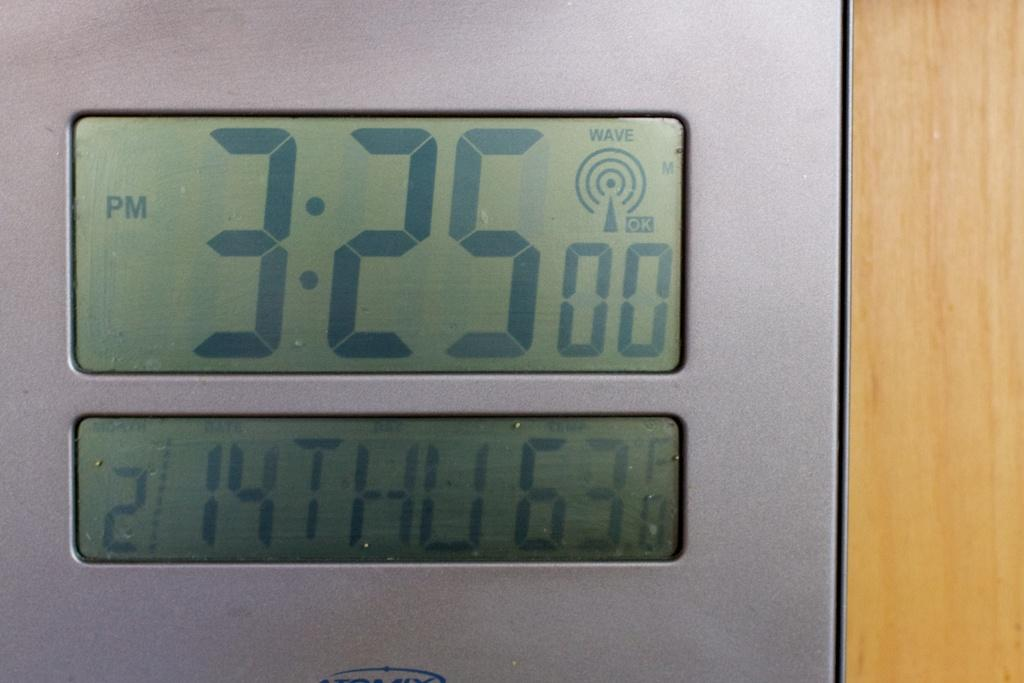<image>
Share a concise interpretation of the image provided. A digital clock with the time 3:25pm and the day is Thursday 